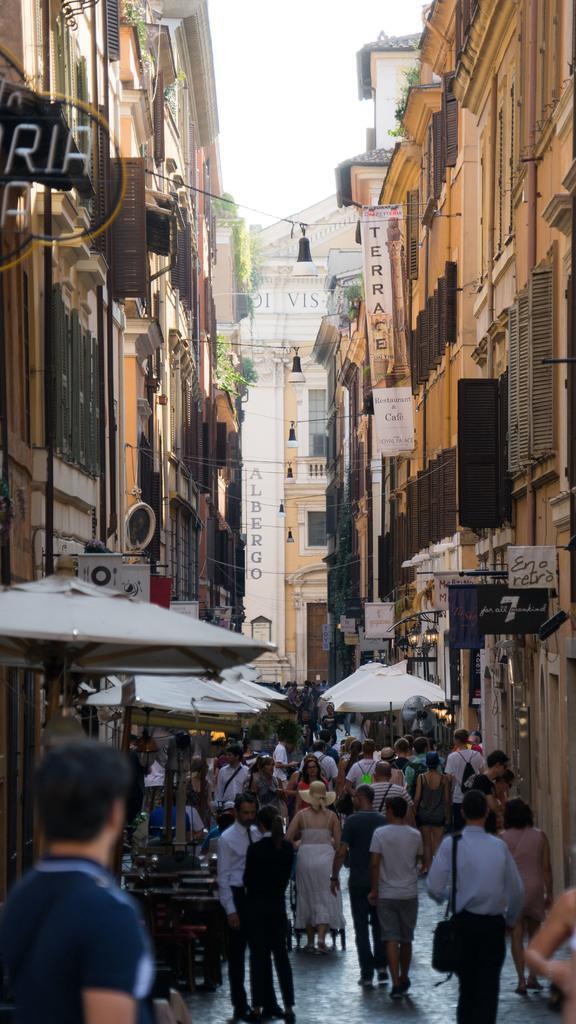How would you summarize this image in a sentence or two? In this image I can see the group of people with different color dresses. On both sides of these people I can see the tents and the buildings with many boards. In the background I can see few more buildings and the sky. 